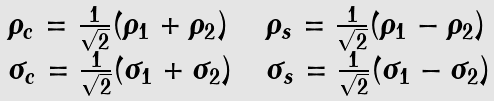Convert formula to latex. <formula><loc_0><loc_0><loc_500><loc_500>\begin{array} { l l l } \rho _ { c } = \frac { 1 } { \sqrt { 2 } } ( \rho _ { 1 } + \rho _ { 2 } ) & & \rho _ { s } = \frac { 1 } { \sqrt { 2 } } ( \rho _ { 1 } - \rho _ { 2 } ) \\ \sigma _ { c } = \frac { 1 } { \sqrt { 2 } } ( \sigma _ { 1 } + \sigma _ { 2 } ) & & \sigma _ { s } = \frac { 1 } { \sqrt { 2 } } ( \sigma _ { 1 } - \sigma _ { 2 } ) \end{array}</formula> 